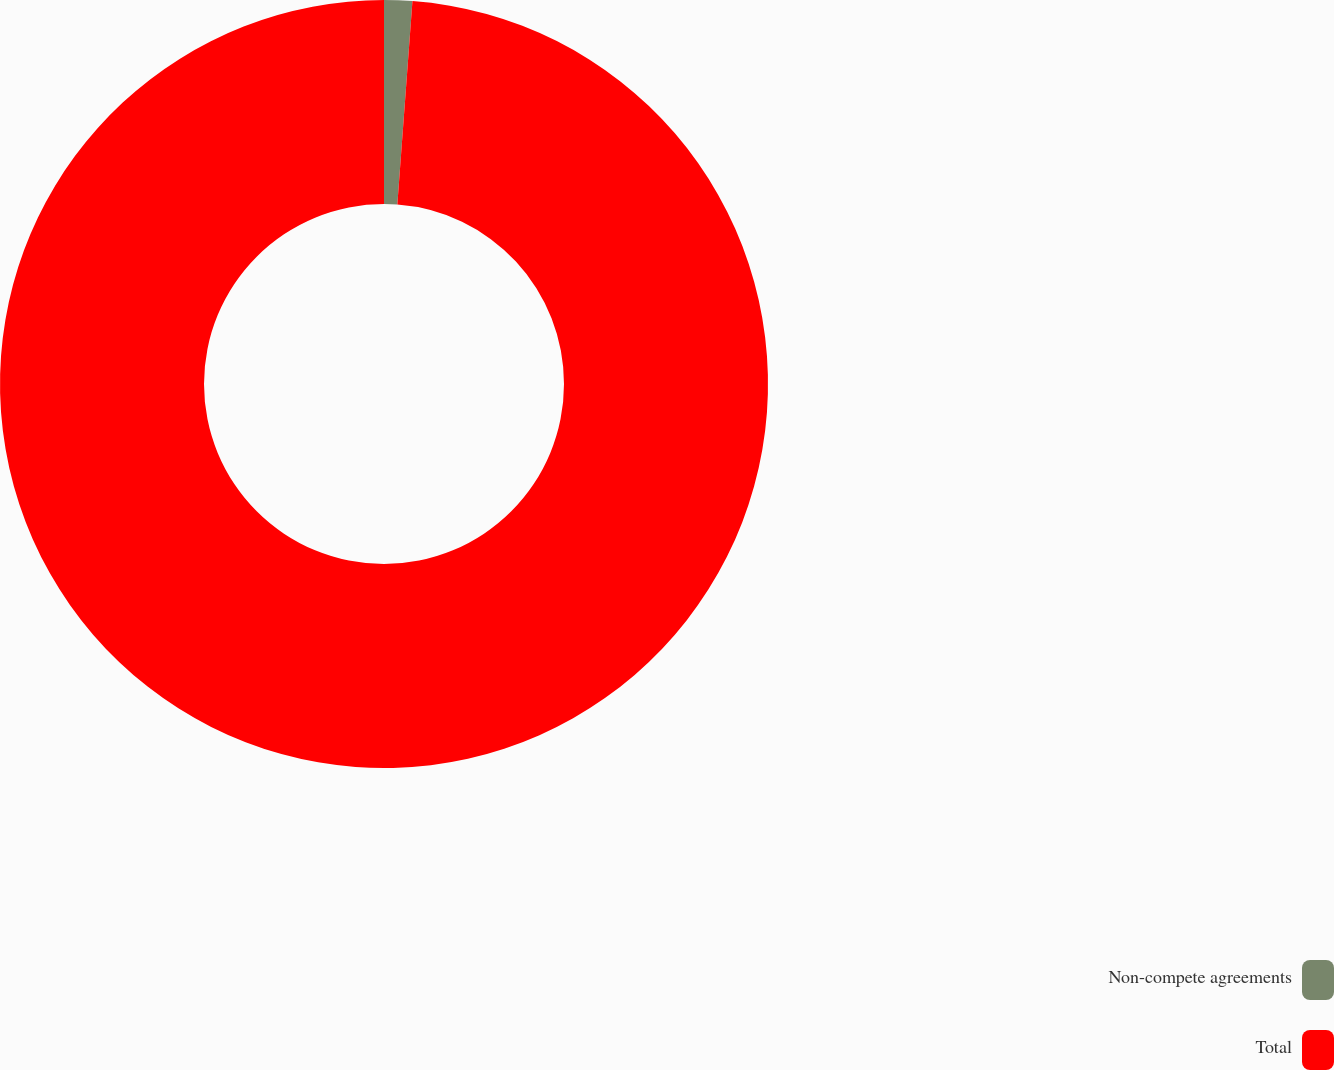Convert chart. <chart><loc_0><loc_0><loc_500><loc_500><pie_chart><fcel>Non-compete agreements<fcel>Total<nl><fcel>1.18%<fcel>98.82%<nl></chart> 